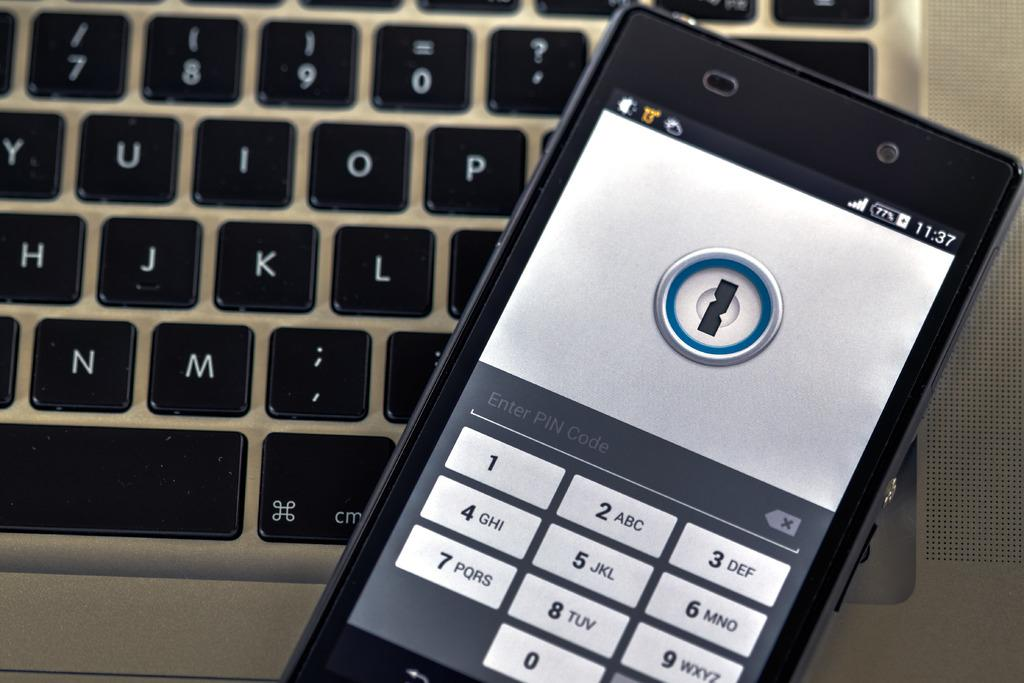<image>
Present a compact description of the photo's key features. A phone that's on top of a laptop keyboard shows that the time is 11:37 